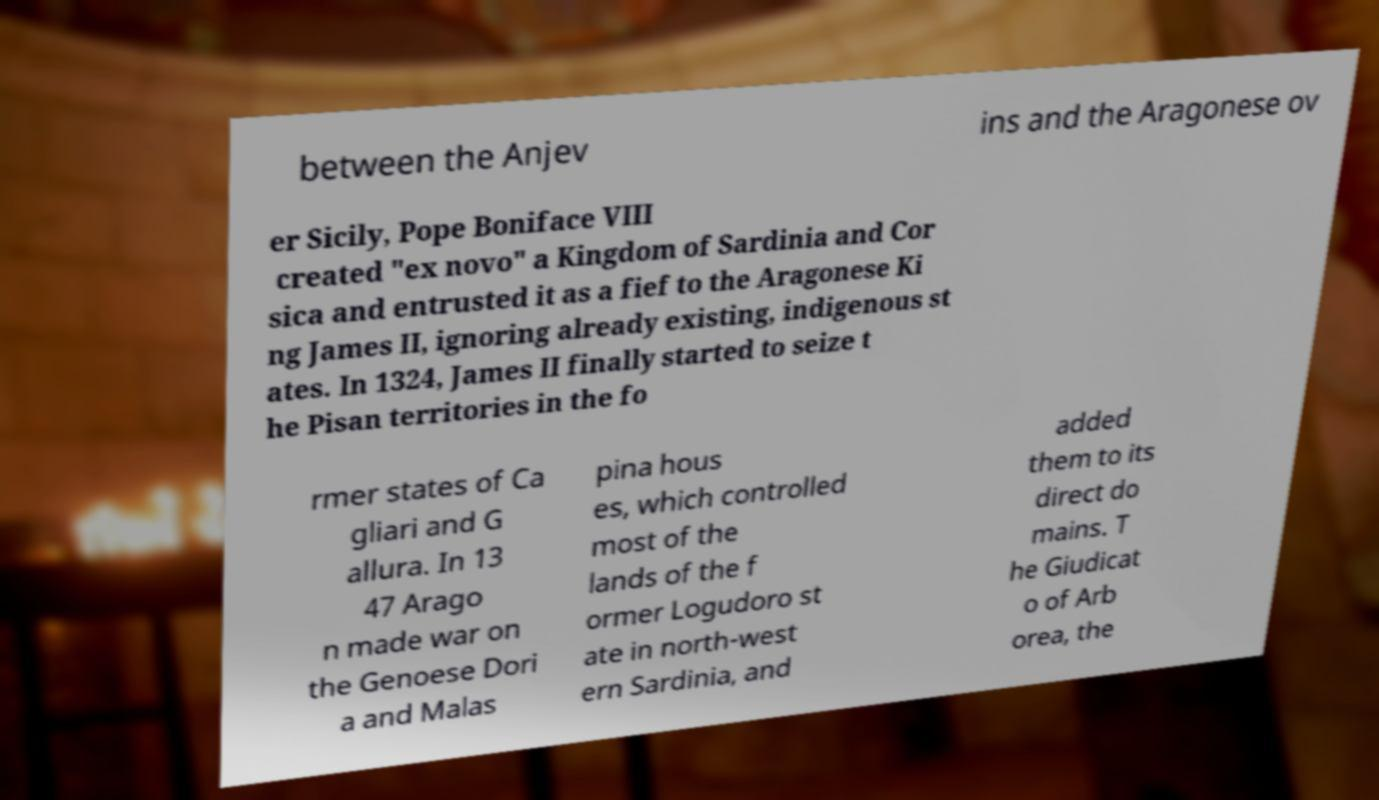Could you extract and type out the text from this image? between the Anjev ins and the Aragonese ov er Sicily, Pope Boniface VIII created "ex novo" a Kingdom of Sardinia and Cor sica and entrusted it as a fief to the Aragonese Ki ng James II, ignoring already existing, indigenous st ates. In 1324, James II finally started to seize t he Pisan territories in the fo rmer states of Ca gliari and G allura. In 13 47 Arago n made war on the Genoese Dori a and Malas pina hous es, which controlled most of the lands of the f ormer Logudoro st ate in north-west ern Sardinia, and added them to its direct do mains. T he Giudicat o of Arb orea, the 